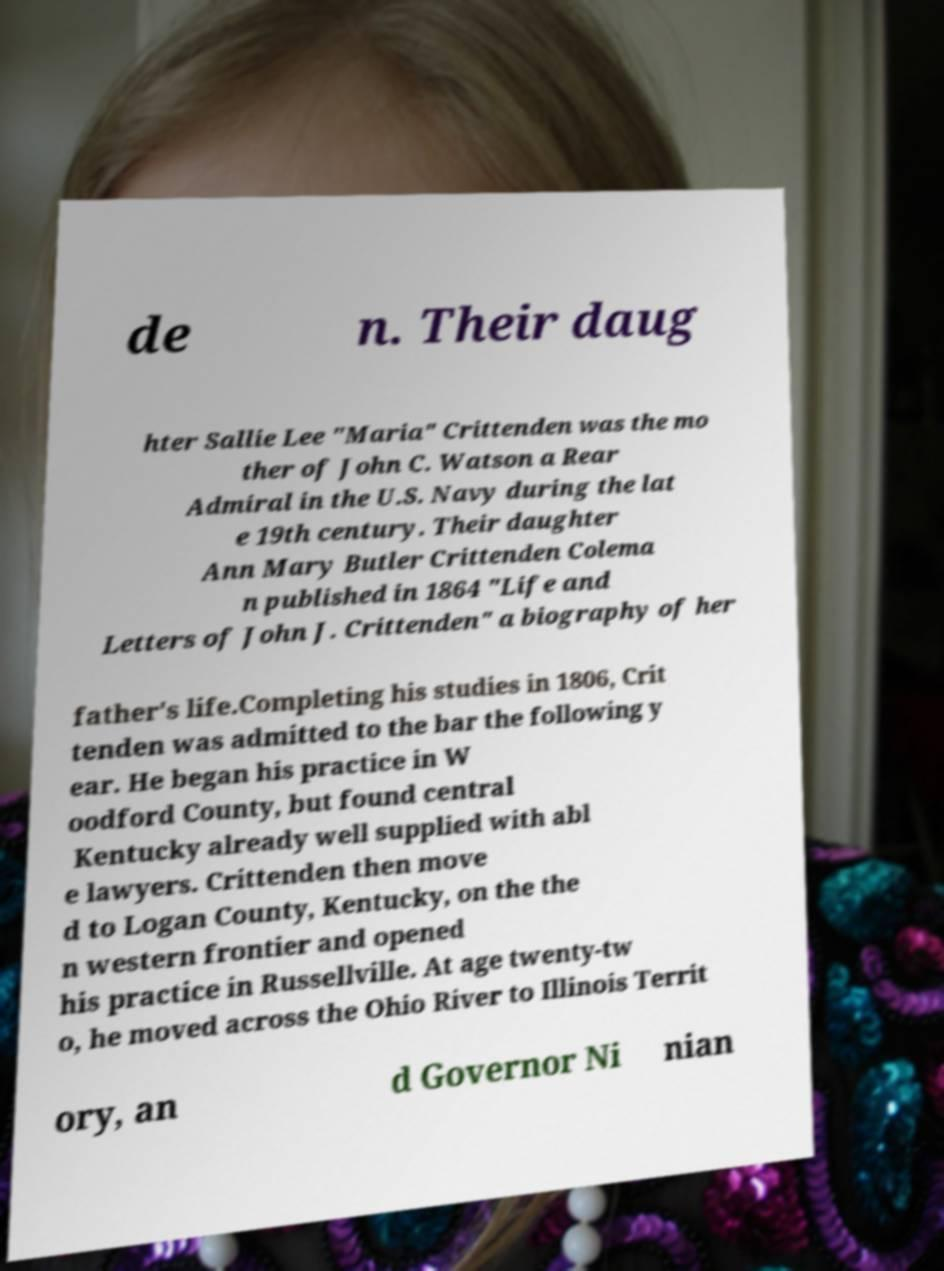Could you assist in decoding the text presented in this image and type it out clearly? de n. Their daug hter Sallie Lee "Maria" Crittenden was the mo ther of John C. Watson a Rear Admiral in the U.S. Navy during the lat e 19th century. Their daughter Ann Mary Butler Crittenden Colema n published in 1864 "Life and Letters of John J. Crittenden" a biography of her father's life.Completing his studies in 1806, Crit tenden was admitted to the bar the following y ear. He began his practice in W oodford County, but found central Kentucky already well supplied with abl e lawyers. Crittenden then move d to Logan County, Kentucky, on the the n western frontier and opened his practice in Russellville. At age twenty-tw o, he moved across the Ohio River to Illinois Territ ory, an d Governor Ni nian 